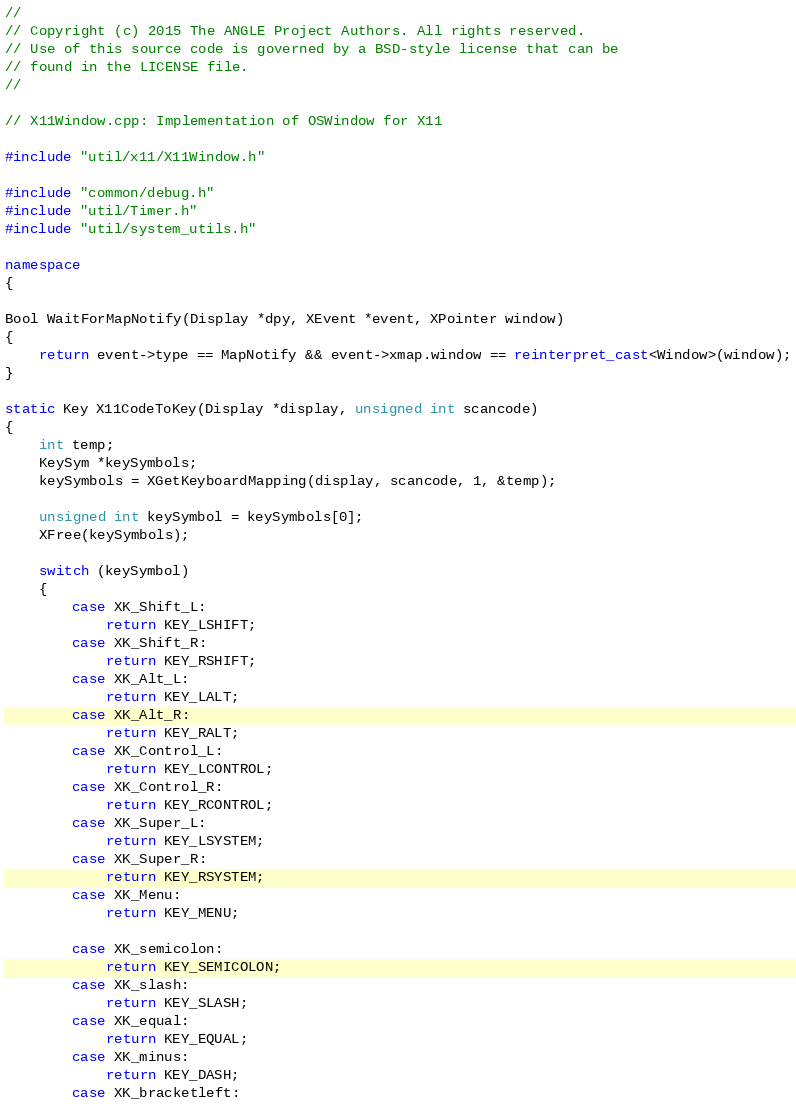Convert code to text. <code><loc_0><loc_0><loc_500><loc_500><_C++_>//
// Copyright (c) 2015 The ANGLE Project Authors. All rights reserved.
// Use of this source code is governed by a BSD-style license that can be
// found in the LICENSE file.
//

// X11Window.cpp: Implementation of OSWindow for X11

#include "util/x11/X11Window.h"

#include "common/debug.h"
#include "util/Timer.h"
#include "util/system_utils.h"

namespace
{

Bool WaitForMapNotify(Display *dpy, XEvent *event, XPointer window)
{
    return event->type == MapNotify && event->xmap.window == reinterpret_cast<Window>(window);
}

static Key X11CodeToKey(Display *display, unsigned int scancode)
{
    int temp;
    KeySym *keySymbols;
    keySymbols = XGetKeyboardMapping(display, scancode, 1, &temp);

    unsigned int keySymbol = keySymbols[0];
    XFree(keySymbols);

    switch (keySymbol)
    {
        case XK_Shift_L:
            return KEY_LSHIFT;
        case XK_Shift_R:
            return KEY_RSHIFT;
        case XK_Alt_L:
            return KEY_LALT;
        case XK_Alt_R:
            return KEY_RALT;
        case XK_Control_L:
            return KEY_LCONTROL;
        case XK_Control_R:
            return KEY_RCONTROL;
        case XK_Super_L:
            return KEY_LSYSTEM;
        case XK_Super_R:
            return KEY_RSYSTEM;
        case XK_Menu:
            return KEY_MENU;

        case XK_semicolon:
            return KEY_SEMICOLON;
        case XK_slash:
            return KEY_SLASH;
        case XK_equal:
            return KEY_EQUAL;
        case XK_minus:
            return KEY_DASH;
        case XK_bracketleft:</code> 